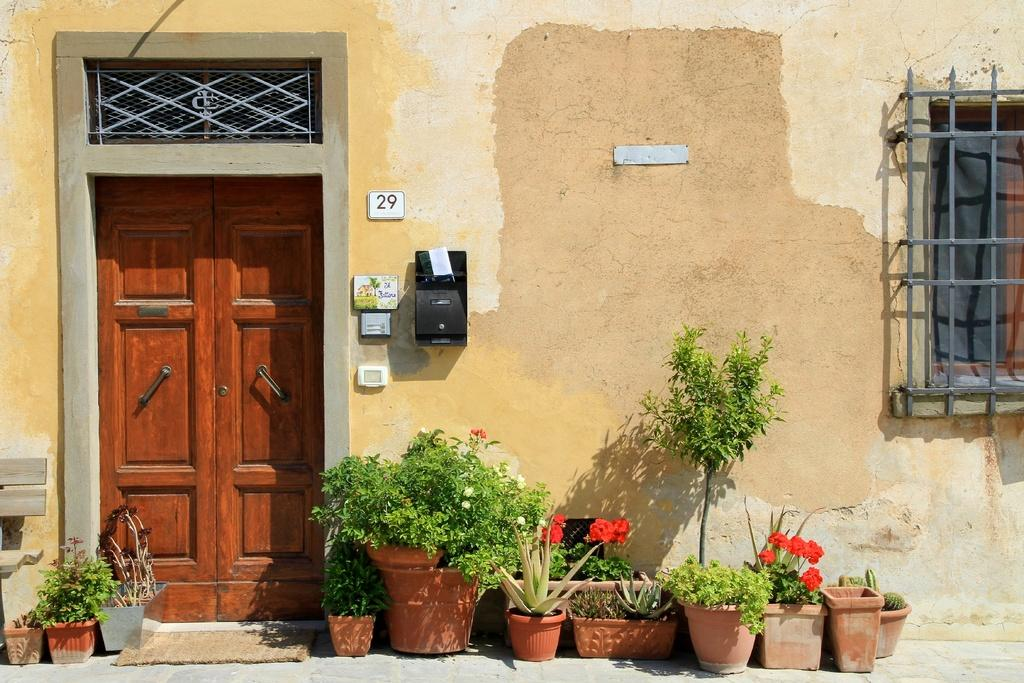What type of structure is visible in the image? There is a house in the image. What can be seen in front of the house? There are flower plants and small bushes in front of the house. Can you describe the window on the right side of the house? There is a window on the right side of the house. What is located in front of the wall in the image? There is a post box in front of the wall. What type of form does the hope take in the image? There is no representation of hope in the image; it only features a house, flower plants, small bushes, a window, and a post box. 